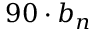<formula> <loc_0><loc_0><loc_500><loc_500>9 0 \cdot b _ { n }</formula> 